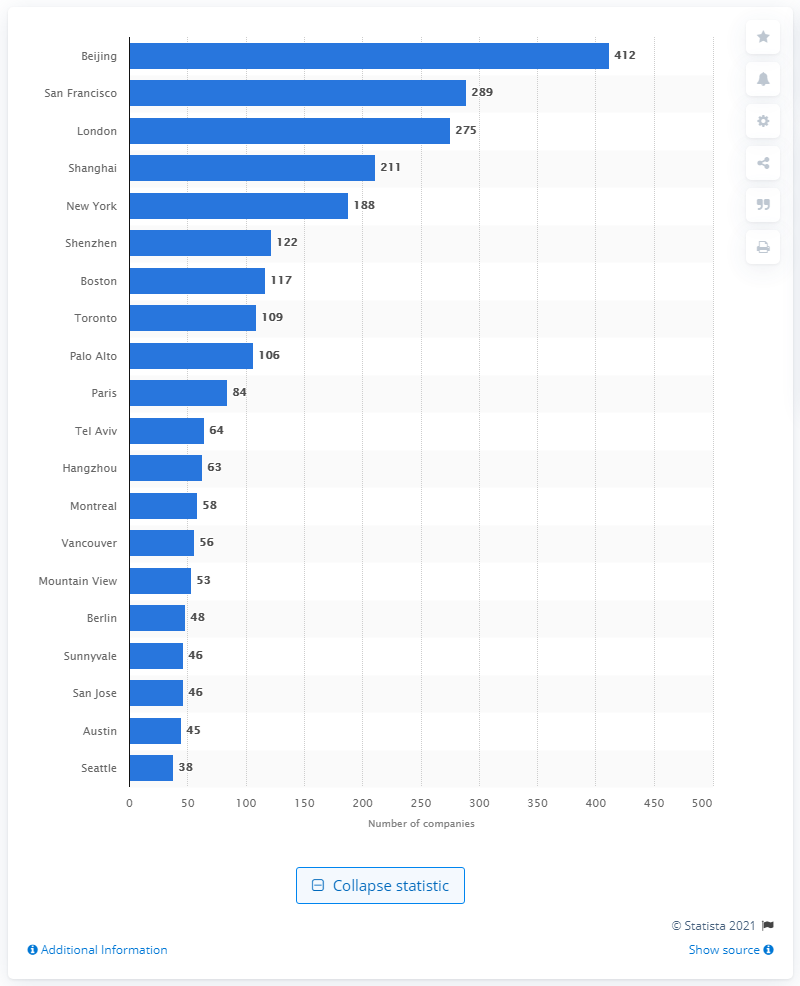Outline some significant characteristics in this image. There were 412 AI companies operating in Beijing during the first half of 2018. 